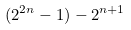Convert formula to latex. <formula><loc_0><loc_0><loc_500><loc_500>( 2 ^ { 2 n } - 1 ) - 2 ^ { n + 1 }</formula> 